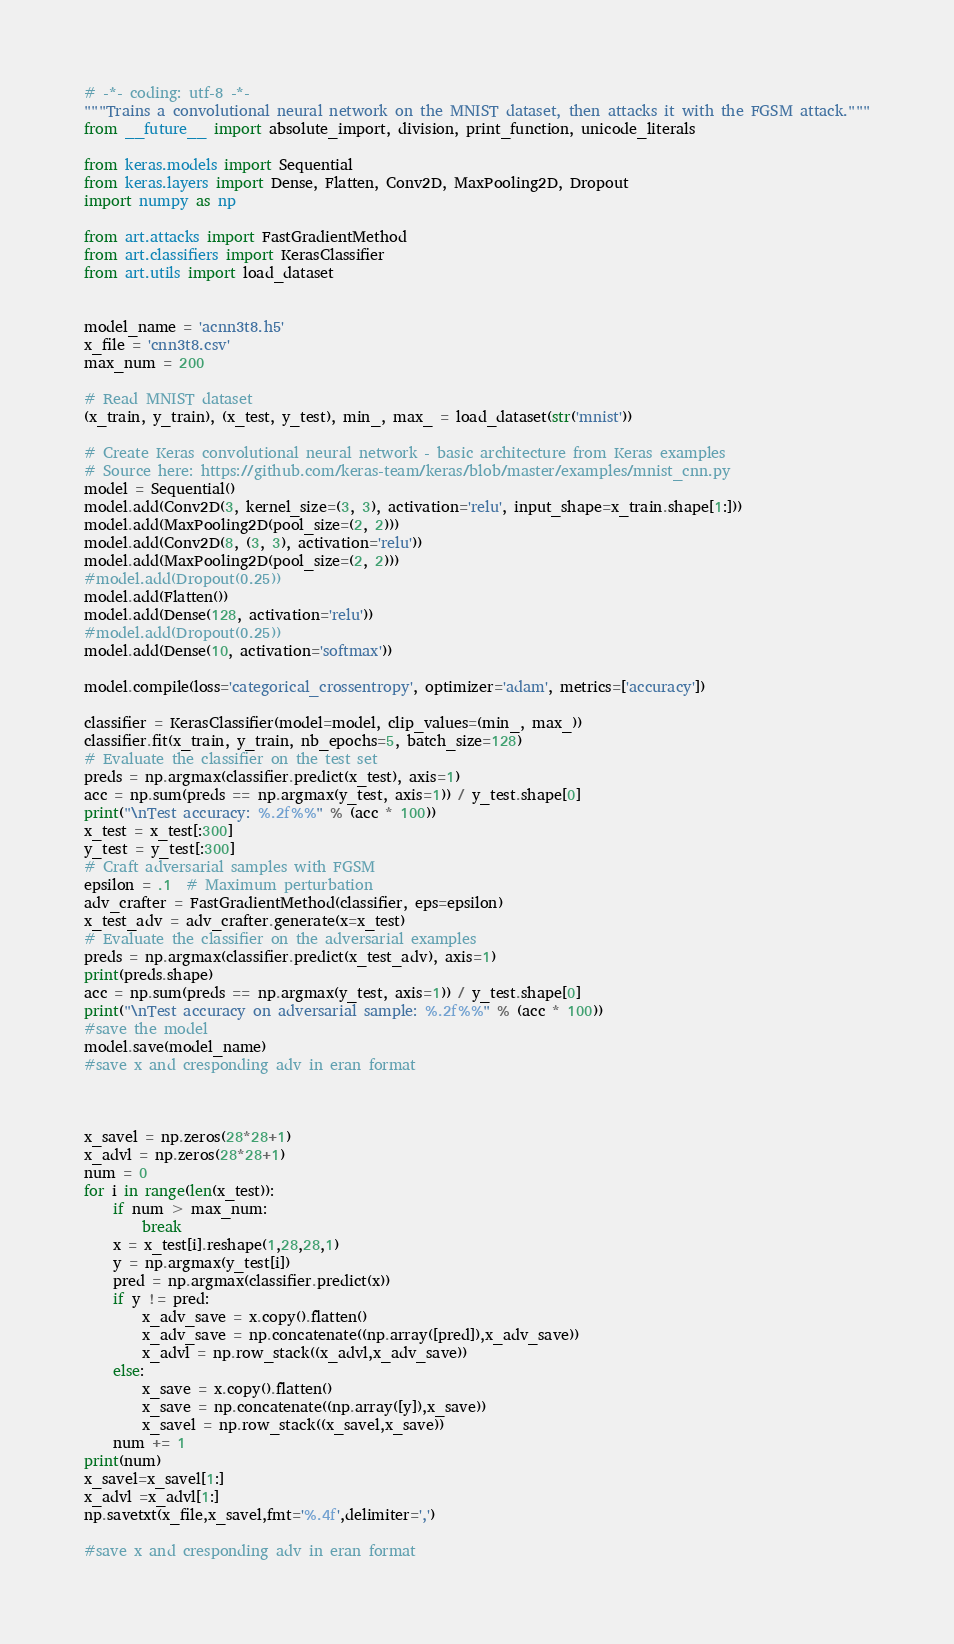<code> <loc_0><loc_0><loc_500><loc_500><_Python_># -*- coding: utf-8 -*-
"""Trains a convolutional neural network on the MNIST dataset, then attacks it with the FGSM attack."""
from __future__ import absolute_import, division, print_function, unicode_literals

from keras.models import Sequential
from keras.layers import Dense, Flatten, Conv2D, MaxPooling2D, Dropout
import numpy as np

from art.attacks import FastGradientMethod
from art.classifiers import KerasClassifier
from art.utils import load_dataset


model_name = 'acnn3t8.h5'
x_file = 'cnn3t8.csv'
max_num = 200

# Read MNIST dataset
(x_train, y_train), (x_test, y_test), min_, max_ = load_dataset(str('mnist'))

# Create Keras convolutional neural network - basic architecture from Keras examples
# Source here: https://github.com/keras-team/keras/blob/master/examples/mnist_cnn.py
model = Sequential()
model.add(Conv2D(3, kernel_size=(3, 3), activation='relu', input_shape=x_train.shape[1:]))
model.add(MaxPooling2D(pool_size=(2, 2)))
model.add(Conv2D(8, (3, 3), activation='relu'))
model.add(MaxPooling2D(pool_size=(2, 2)))
#model.add(Dropout(0.25))
model.add(Flatten())
model.add(Dense(128, activation='relu'))
#model.add(Dropout(0.25))
model.add(Dense(10, activation='softmax'))

model.compile(loss='categorical_crossentropy', optimizer='adam', metrics=['accuracy'])

classifier = KerasClassifier(model=model, clip_values=(min_, max_))
classifier.fit(x_train, y_train, nb_epochs=5, batch_size=128)
# Evaluate the classifier on the test set
preds = np.argmax(classifier.predict(x_test), axis=1)
acc = np.sum(preds == np.argmax(y_test, axis=1)) / y_test.shape[0]
print("\nTest accuracy: %.2f%%" % (acc * 100))
x_test = x_test[:300]
y_test = y_test[:300]
# Craft adversarial samples with FGSM
epsilon = .1  # Maximum perturbation
adv_crafter = FastGradientMethod(classifier, eps=epsilon)
x_test_adv = adv_crafter.generate(x=x_test)
# Evaluate the classifier on the adversarial examples
preds = np.argmax(classifier.predict(x_test_adv), axis=1)
print(preds.shape)
acc = np.sum(preds == np.argmax(y_test, axis=1)) / y_test.shape[0]
print("\nTest accuracy on adversarial sample: %.2f%%" % (acc * 100))
#save the model
model.save(model_name)
#save x and cresponding adv in eran format



x_savel = np.zeros(28*28+1)
x_advl = np.zeros(28*28+1)
num = 0
for i in range(len(x_test)):
    if num > max_num:
        break
    x = x_test[i].reshape(1,28,28,1)
    y = np.argmax(y_test[i])
    pred = np.argmax(classifier.predict(x))
    if y != pred:
        x_adv_save = x.copy().flatten()
        x_adv_save = np.concatenate((np.array([pred]),x_adv_save))
        x_advl = np.row_stack((x_advl,x_adv_save))
    else:
        x_save = x.copy().flatten()
        x_save = np.concatenate((np.array([y]),x_save))
        x_savel = np.row_stack((x_savel,x_save))
    num += 1
print(num)
x_savel=x_savel[1:]
x_advl =x_advl[1:]
np.savetxt(x_file,x_savel,fmt='%.4f',delimiter=',')

#save x and cresponding adv in eran format
</code> 